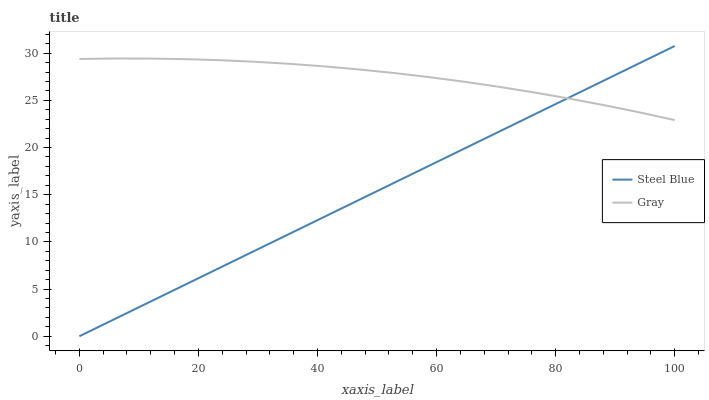Does Steel Blue have the maximum area under the curve?
Answer yes or no. No. Is Steel Blue the roughest?
Answer yes or no. No. 